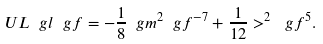Convert formula to latex. <formula><loc_0><loc_0><loc_500><loc_500>\ U L { \ g l } \ g f = - \frac { 1 } { 8 } \ g m ^ { 2 } \ g f ^ { - 7 } + \frac { 1 } { 1 2 } > ^ { 2 } \ g f ^ { 5 } .</formula> 